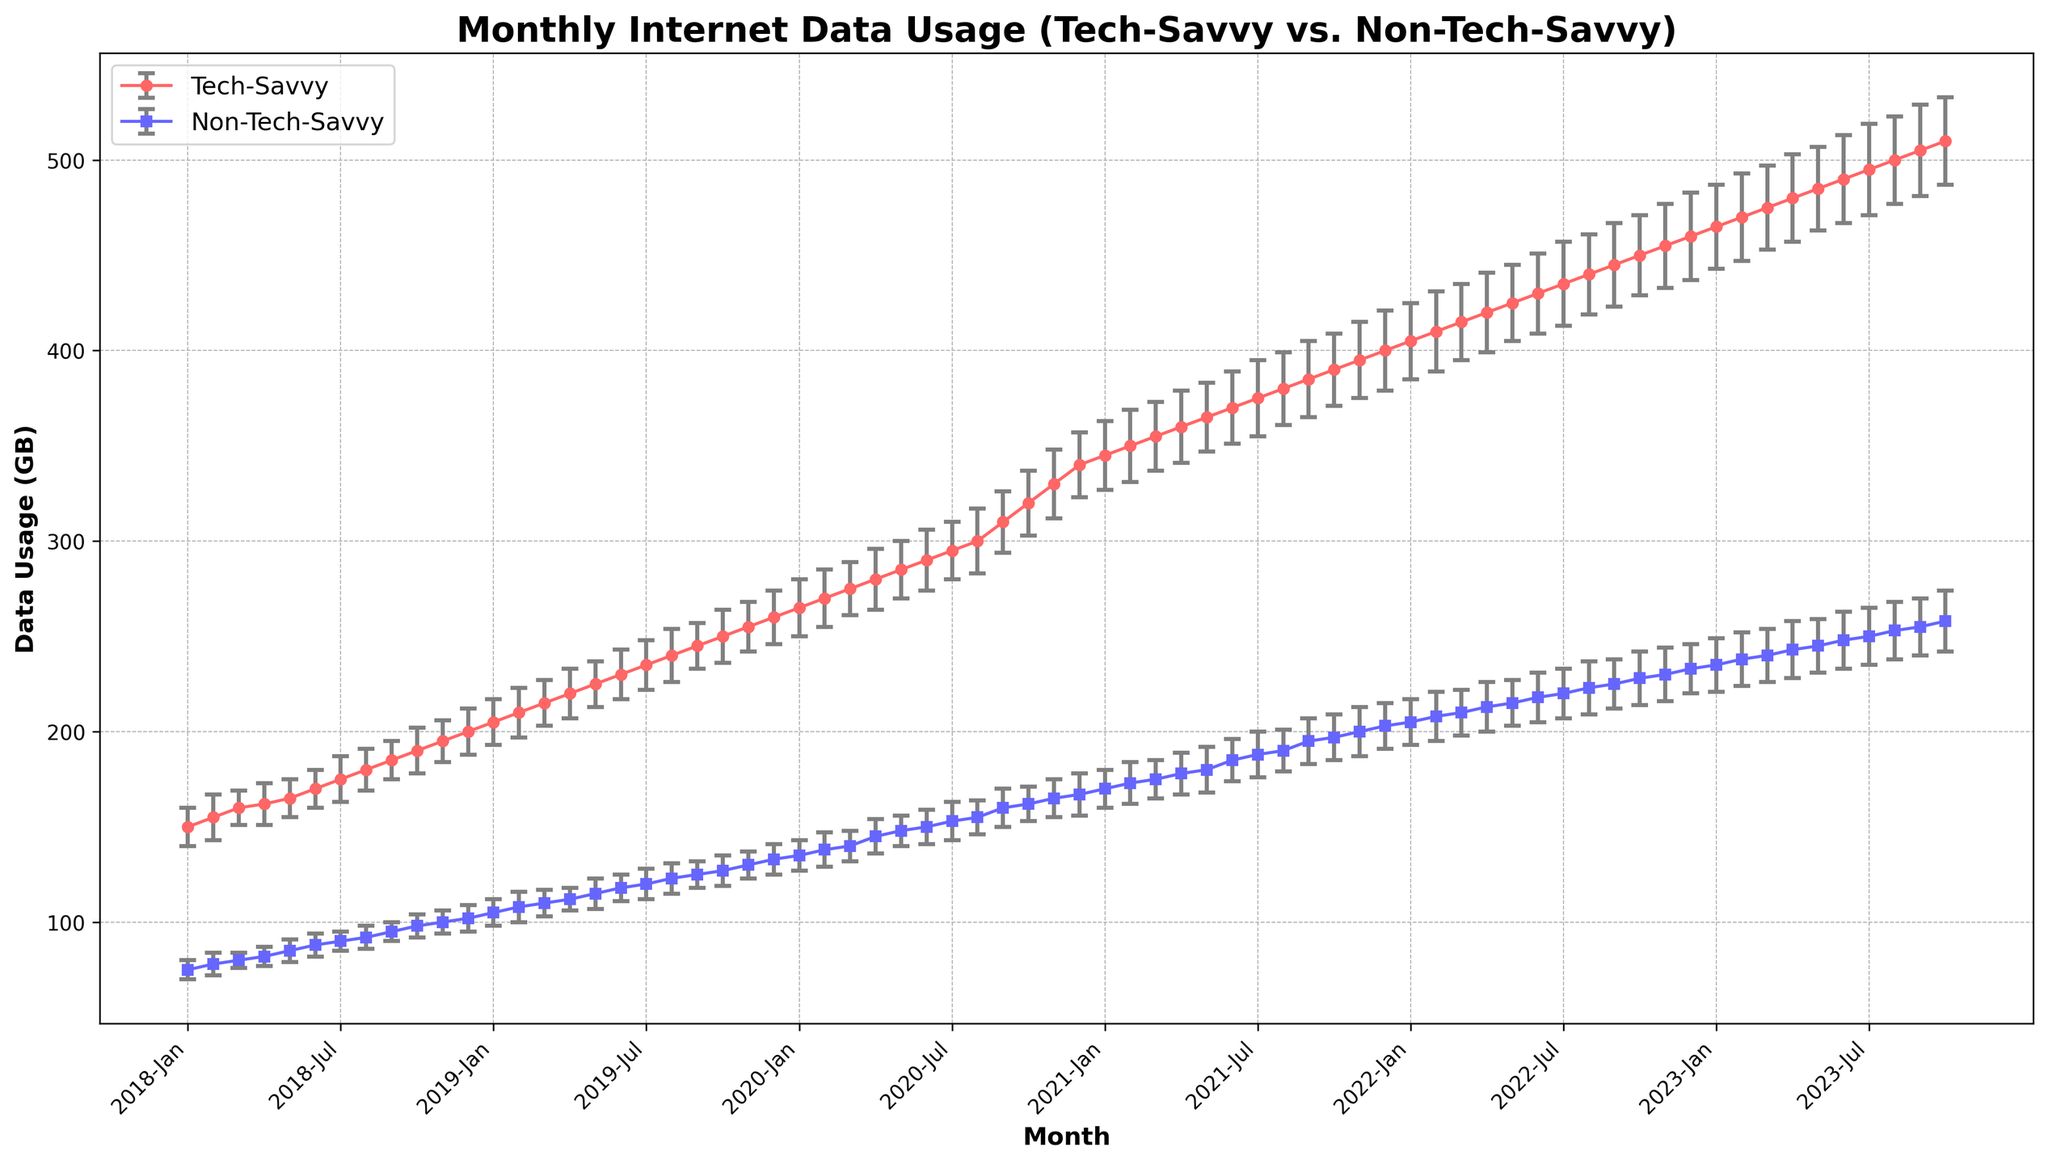What is the trend in data usage for Tech-Savvy users over the past five years? The data usage for Tech-Savvy users increases steadily over the five years. This can be seen by the upward slope in the red line representing Tech-Savvy users, indicating consistent growth in data usage each month.
Answer: Consistently increasing Which group had higher data usage in December 2019? Compare the data usage values for December 2019 from both groups. Tech-Savvy users had 260 GB and Non-Tech-Savvy users had 133 GB. Thus, Tech-Savvy users had higher data usage.
Answer: Tech-Savvy What is the average data usage for Non-Tech-Savvy users in the year 2021? To find this, sum all the data usage values for Non-Tech-Savvy users in 2021 and divide by the number of months (12). The values are: 170, 173, 175, 178, 180, 185, 188, 190, 195, 197, 200, and 203. The sum is 2234 GB. Dividing by 12 gives an average of approximately 186.17 GB.
Answer: 186.17 GB During which month was the data usage for Tech-Savvy users the highest? Look for the maximum data usage value in the Tech-Savvy series. The highest value is 510 GB in October 2023.
Answer: October 2023 What is the difference in data usage between Tech-Savvy and Non-Tech-Savvy users in January 2023? Subtract the Non-Tech-Savvy data usage from the Tech-Savvy data usage for January 2023. Tech-Savvy users had 465 GB and Non-Tech-Savvy users had 235 GB. So, the difference is 465 - 235 = 230 GB.
Answer: 230 GB What was the pattern of standard deviation for Tech-Savvy users from 2018 to 2020? The standard deviation for Tech-Savvy users starts around 10-12 GB in 2018 and gradually increases to around 17-18 GB by the end of 2020. This indicates growing variability in data usage among Tech-Savvy users over these years.
Answer: Increasing How does the data usage of Non-Tech-Savvy users in July 2020 compare to that in July 2021? Compare the values for Non-Tech-Savvy users in July 2020 (153 GB) and July 2021 (188 GB). It shows a significant increase.
Answer: Increased What is the overall trend in the standard deviation for Non-Tech-Savvy users over the entire period? The standard deviation for Non-Tech-Savvy users fluctuates but generally trends upward, indicating increasing variability in data usage. The line with square markers shows this trend.
Answer: Generally increasing In which year did Tech-Savvy users see the most significant monthly increase in data usage? By observing the red line for Tech-Savvy users, the most significant monthly increase in data usage appears between Aug 2020 (300 GB) and Sep 2020 (310 GB), with a sharp slope. This is a 10 GB increase within a single month.
Answer: 2020 